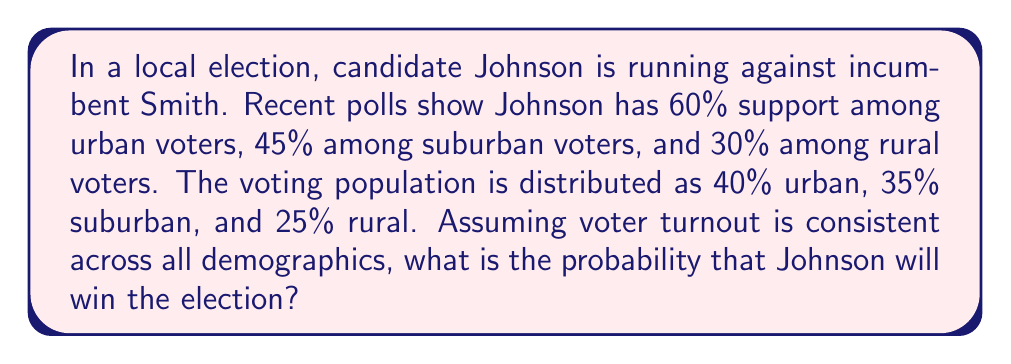Could you help me with this problem? Let's approach this step-by-step:

1) First, we need to calculate the overall percentage of votes Johnson is expected to receive:

   Urban: $0.60 \times 0.40 = 0.24$ or 24%
   Suburban: $0.45 \times 0.35 = 0.1575$ or 15.75%
   Rural: $0.30 \times 0.25 = 0.075$ or 7.5%

2) Total expected vote share for Johnson:
   
   $$ 0.24 + 0.1575 + 0.075 = 0.4725 \text{ or } 47.25\% $$

3) For Johnson to win, he needs more than 50% of the votes. The probability of winning is the probability of getting more than 50% of the votes.

4) Assuming a large number of voters, we can approximate the distribution of actual vote share as a normal distribution centered around the expected vote share (47.25%).

5) To calculate the probability, we need to know the standard deviation of this distribution. Let's assume a standard deviation of 2% (0.02), which is typical for well-conducted polls.

6) We can then use the z-score formula:

   $$ z = \frac{x - \mu}{\sigma} $$

   Where $x$ is the threshold (50%), $\mu$ is the expected vote share (47.25%), and $\sigma$ is the standard deviation (2%).

7) Plugging in the values:

   $$ z = \frac{0.50 - 0.4725}{0.02} = 1.375 $$

8) The probability of Johnson winning is the area to the right of z = 1.375 under the standard normal curve. We can look this up in a z-table or use a calculator.

9) This probability is approximately 0.0845 or 8.45%.

Therefore, based on the given demographic data and voting patterns, Johnson has about an 8.45% chance of winning the election.
Answer: 8.45% 